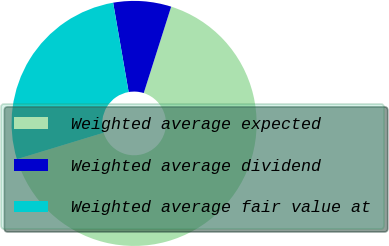Convert chart to OTSL. <chart><loc_0><loc_0><loc_500><loc_500><pie_chart><fcel>Weighted average expected<fcel>Weighted average dividend<fcel>Weighted average fair value at<nl><fcel>65.4%<fcel>7.63%<fcel>26.98%<nl></chart> 